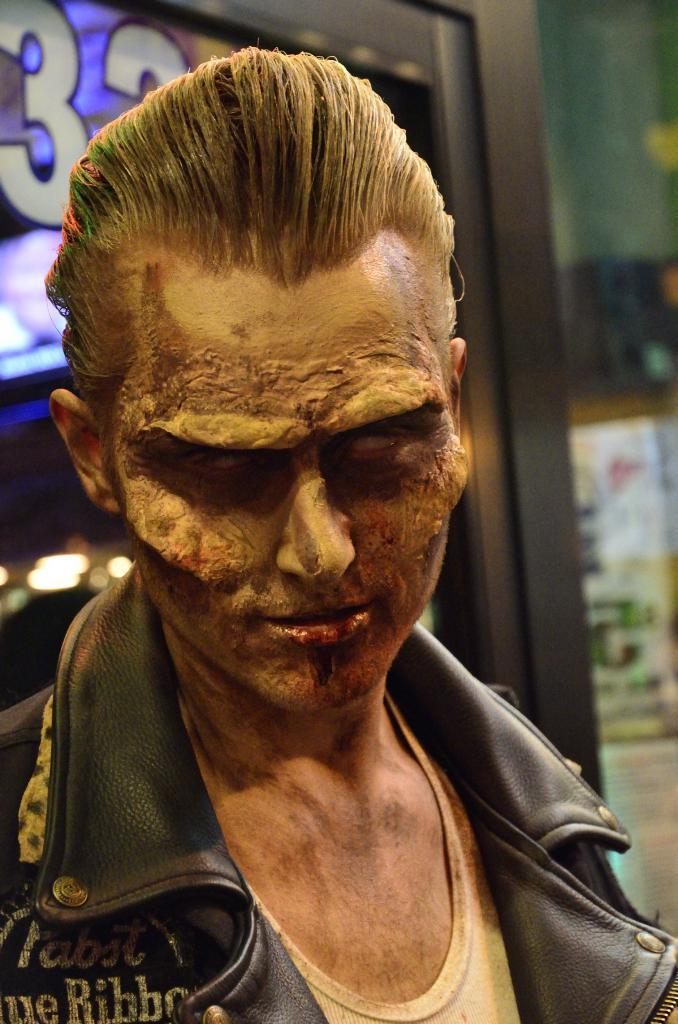What is the main subject in the center of the image? There is a person with costumes in the center of the image. What can be seen in the background of the image? There are buildings and lights visible in the background of the image. What type of bubble can be seen floating near the person with costumes in the image? There is no bubble present in the image. 